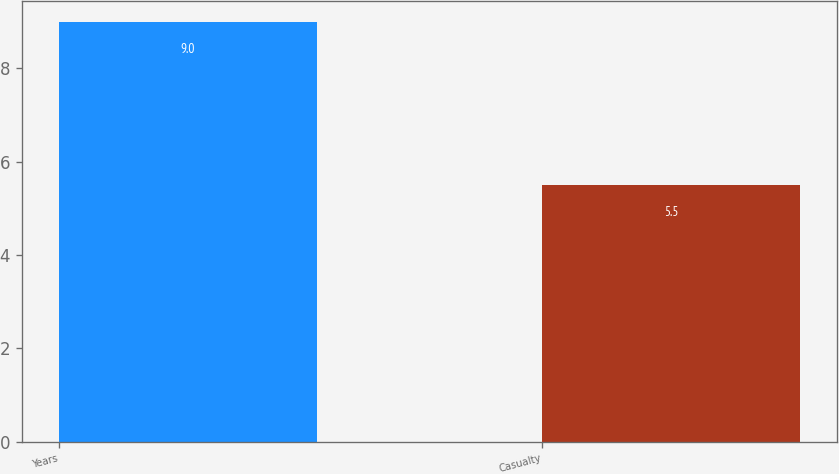Convert chart. <chart><loc_0><loc_0><loc_500><loc_500><bar_chart><fcel>Years<fcel>Casualty<nl><fcel>9<fcel>5.5<nl></chart> 